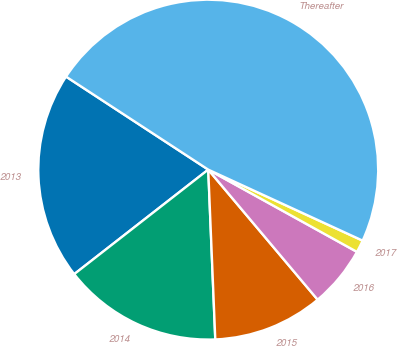Convert chart. <chart><loc_0><loc_0><loc_500><loc_500><pie_chart><fcel>2013<fcel>2014<fcel>2015<fcel>2016<fcel>2017<fcel>Thereafter<nl><fcel>19.76%<fcel>15.12%<fcel>10.47%<fcel>5.83%<fcel>1.18%<fcel>47.64%<nl></chart> 